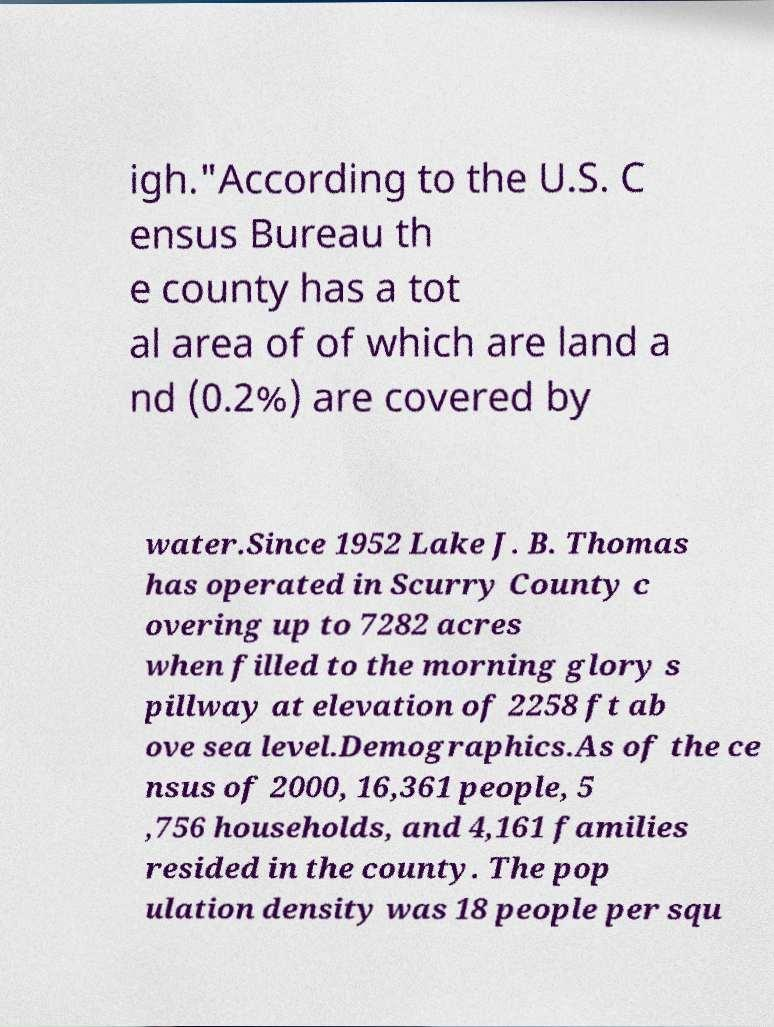Could you assist in decoding the text presented in this image and type it out clearly? igh."According to the U.S. C ensus Bureau th e county has a tot al area of of which are land a nd (0.2%) are covered by water.Since 1952 Lake J. B. Thomas has operated in Scurry County c overing up to 7282 acres when filled to the morning glory s pillway at elevation of 2258 ft ab ove sea level.Demographics.As of the ce nsus of 2000, 16,361 people, 5 ,756 households, and 4,161 families resided in the county. The pop ulation density was 18 people per squ 